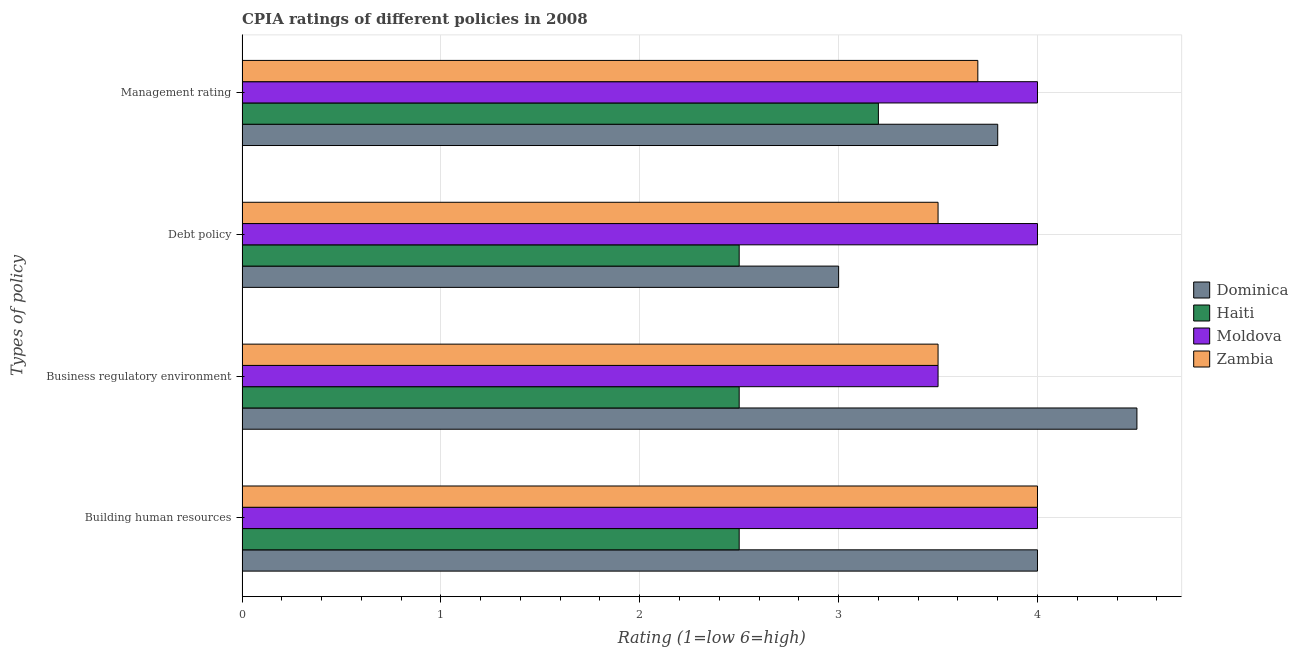How many groups of bars are there?
Your answer should be very brief. 4. Are the number of bars on each tick of the Y-axis equal?
Your response must be concise. Yes. How many bars are there on the 1st tick from the top?
Give a very brief answer. 4. What is the label of the 2nd group of bars from the top?
Provide a short and direct response. Debt policy. What is the cpia rating of building human resources in Haiti?
Offer a terse response. 2.5. Across all countries, what is the maximum cpia rating of management?
Provide a succinct answer. 4. Across all countries, what is the minimum cpia rating of management?
Your answer should be compact. 3.2. In which country was the cpia rating of business regulatory environment maximum?
Offer a very short reply. Dominica. In which country was the cpia rating of debt policy minimum?
Provide a succinct answer. Haiti. What is the difference between the cpia rating of debt policy in Dominica and the cpia rating of business regulatory environment in Zambia?
Your answer should be compact. -0.5. What is the average cpia rating of debt policy per country?
Offer a very short reply. 3.25. What is the difference between the cpia rating of business regulatory environment and cpia rating of building human resources in Dominica?
Provide a short and direct response. 0.5. In how many countries, is the cpia rating of debt policy greater than the average cpia rating of debt policy taken over all countries?
Make the answer very short. 2. Is it the case that in every country, the sum of the cpia rating of debt policy and cpia rating of business regulatory environment is greater than the sum of cpia rating of building human resources and cpia rating of management?
Keep it short and to the point. No. What does the 2nd bar from the top in Business regulatory environment represents?
Make the answer very short. Moldova. What does the 3rd bar from the bottom in Building human resources represents?
Your answer should be compact. Moldova. How many bars are there?
Give a very brief answer. 16. Are all the bars in the graph horizontal?
Your response must be concise. Yes. What is the difference between two consecutive major ticks on the X-axis?
Your response must be concise. 1. Does the graph contain any zero values?
Your answer should be compact. No. Does the graph contain grids?
Make the answer very short. Yes. Where does the legend appear in the graph?
Provide a short and direct response. Center right. What is the title of the graph?
Provide a short and direct response. CPIA ratings of different policies in 2008. What is the label or title of the X-axis?
Your answer should be compact. Rating (1=low 6=high). What is the label or title of the Y-axis?
Your answer should be compact. Types of policy. What is the Rating (1=low 6=high) in Dominica in Building human resources?
Keep it short and to the point. 4. What is the Rating (1=low 6=high) of Haiti in Building human resources?
Keep it short and to the point. 2.5. What is the Rating (1=low 6=high) of Zambia in Building human resources?
Offer a very short reply. 4. What is the Rating (1=low 6=high) of Haiti in Business regulatory environment?
Your answer should be very brief. 2.5. What is the Rating (1=low 6=high) in Haiti in Debt policy?
Make the answer very short. 2.5. What is the Rating (1=low 6=high) of Moldova in Debt policy?
Offer a very short reply. 4. What is the Rating (1=low 6=high) of Zambia in Debt policy?
Keep it short and to the point. 3.5. What is the Rating (1=low 6=high) in Dominica in Management rating?
Provide a succinct answer. 3.8. What is the Rating (1=low 6=high) of Moldova in Management rating?
Keep it short and to the point. 4. Across all Types of policy, what is the maximum Rating (1=low 6=high) of Moldova?
Offer a terse response. 4. Across all Types of policy, what is the minimum Rating (1=low 6=high) of Dominica?
Your answer should be compact. 3. What is the total Rating (1=low 6=high) of Haiti in the graph?
Make the answer very short. 10.7. What is the total Rating (1=low 6=high) in Moldova in the graph?
Offer a terse response. 15.5. What is the total Rating (1=low 6=high) in Zambia in the graph?
Offer a terse response. 14.7. What is the difference between the Rating (1=low 6=high) of Haiti in Building human resources and that in Business regulatory environment?
Your answer should be very brief. 0. What is the difference between the Rating (1=low 6=high) in Moldova in Building human resources and that in Business regulatory environment?
Offer a very short reply. 0.5. What is the difference between the Rating (1=low 6=high) in Zambia in Building human resources and that in Business regulatory environment?
Your answer should be compact. 0.5. What is the difference between the Rating (1=low 6=high) of Moldova in Building human resources and that in Debt policy?
Offer a very short reply. 0. What is the difference between the Rating (1=low 6=high) of Zambia in Building human resources and that in Debt policy?
Your answer should be compact. 0.5. What is the difference between the Rating (1=low 6=high) in Dominica in Building human resources and that in Management rating?
Provide a succinct answer. 0.2. What is the difference between the Rating (1=low 6=high) in Haiti in Building human resources and that in Management rating?
Keep it short and to the point. -0.7. What is the difference between the Rating (1=low 6=high) of Dominica in Business regulatory environment and that in Debt policy?
Keep it short and to the point. 1.5. What is the difference between the Rating (1=low 6=high) of Zambia in Business regulatory environment and that in Debt policy?
Provide a succinct answer. 0. What is the difference between the Rating (1=low 6=high) in Dominica in Business regulatory environment and that in Management rating?
Ensure brevity in your answer.  0.7. What is the difference between the Rating (1=low 6=high) of Moldova in Business regulatory environment and that in Management rating?
Keep it short and to the point. -0.5. What is the difference between the Rating (1=low 6=high) in Zambia in Business regulatory environment and that in Management rating?
Give a very brief answer. -0.2. What is the difference between the Rating (1=low 6=high) in Haiti in Debt policy and that in Management rating?
Ensure brevity in your answer.  -0.7. What is the difference between the Rating (1=low 6=high) in Moldova in Debt policy and that in Management rating?
Make the answer very short. 0. What is the difference between the Rating (1=low 6=high) in Dominica in Building human resources and the Rating (1=low 6=high) in Moldova in Business regulatory environment?
Your response must be concise. 0.5. What is the difference between the Rating (1=low 6=high) in Haiti in Building human resources and the Rating (1=low 6=high) in Moldova in Business regulatory environment?
Keep it short and to the point. -1. What is the difference between the Rating (1=low 6=high) of Moldova in Building human resources and the Rating (1=low 6=high) of Zambia in Business regulatory environment?
Provide a succinct answer. 0.5. What is the difference between the Rating (1=low 6=high) in Dominica in Building human resources and the Rating (1=low 6=high) in Haiti in Debt policy?
Ensure brevity in your answer.  1.5. What is the difference between the Rating (1=low 6=high) of Dominica in Building human resources and the Rating (1=low 6=high) of Zambia in Debt policy?
Ensure brevity in your answer.  0.5. What is the difference between the Rating (1=low 6=high) of Haiti in Building human resources and the Rating (1=low 6=high) of Zambia in Debt policy?
Ensure brevity in your answer.  -1. What is the difference between the Rating (1=low 6=high) in Dominica in Building human resources and the Rating (1=low 6=high) in Moldova in Management rating?
Give a very brief answer. 0. What is the difference between the Rating (1=low 6=high) in Haiti in Building human resources and the Rating (1=low 6=high) in Moldova in Management rating?
Your answer should be very brief. -1.5. What is the difference between the Rating (1=low 6=high) in Haiti in Building human resources and the Rating (1=low 6=high) in Zambia in Management rating?
Your answer should be very brief. -1.2. What is the difference between the Rating (1=low 6=high) in Dominica in Business regulatory environment and the Rating (1=low 6=high) in Moldova in Debt policy?
Offer a terse response. 0.5. What is the difference between the Rating (1=low 6=high) of Dominica in Business regulatory environment and the Rating (1=low 6=high) of Zambia in Debt policy?
Your response must be concise. 1. What is the difference between the Rating (1=low 6=high) in Haiti in Business regulatory environment and the Rating (1=low 6=high) in Moldova in Debt policy?
Provide a succinct answer. -1.5. What is the difference between the Rating (1=low 6=high) in Haiti in Business regulatory environment and the Rating (1=low 6=high) in Zambia in Debt policy?
Offer a very short reply. -1. What is the difference between the Rating (1=low 6=high) in Dominica in Business regulatory environment and the Rating (1=low 6=high) in Zambia in Management rating?
Offer a terse response. 0.8. What is the difference between the Rating (1=low 6=high) in Dominica in Debt policy and the Rating (1=low 6=high) in Moldova in Management rating?
Make the answer very short. -1. What is the difference between the Rating (1=low 6=high) in Dominica in Debt policy and the Rating (1=low 6=high) in Zambia in Management rating?
Provide a succinct answer. -0.7. What is the difference between the Rating (1=low 6=high) in Haiti in Debt policy and the Rating (1=low 6=high) in Moldova in Management rating?
Offer a terse response. -1.5. What is the average Rating (1=low 6=high) in Dominica per Types of policy?
Give a very brief answer. 3.83. What is the average Rating (1=low 6=high) of Haiti per Types of policy?
Ensure brevity in your answer.  2.67. What is the average Rating (1=low 6=high) in Moldova per Types of policy?
Offer a very short reply. 3.88. What is the average Rating (1=low 6=high) of Zambia per Types of policy?
Offer a very short reply. 3.67. What is the difference between the Rating (1=low 6=high) of Dominica and Rating (1=low 6=high) of Haiti in Building human resources?
Ensure brevity in your answer.  1.5. What is the difference between the Rating (1=low 6=high) of Haiti and Rating (1=low 6=high) of Zambia in Building human resources?
Keep it short and to the point. -1.5. What is the difference between the Rating (1=low 6=high) of Moldova and Rating (1=low 6=high) of Zambia in Building human resources?
Ensure brevity in your answer.  0. What is the difference between the Rating (1=low 6=high) of Dominica and Rating (1=low 6=high) of Haiti in Business regulatory environment?
Ensure brevity in your answer.  2. What is the difference between the Rating (1=low 6=high) in Haiti and Rating (1=low 6=high) in Moldova in Business regulatory environment?
Your answer should be very brief. -1. What is the difference between the Rating (1=low 6=high) in Haiti and Rating (1=low 6=high) in Zambia in Business regulatory environment?
Make the answer very short. -1. What is the difference between the Rating (1=low 6=high) in Moldova and Rating (1=low 6=high) in Zambia in Business regulatory environment?
Give a very brief answer. 0. What is the difference between the Rating (1=low 6=high) of Moldova and Rating (1=low 6=high) of Zambia in Debt policy?
Offer a very short reply. 0.5. What is the difference between the Rating (1=low 6=high) in Dominica and Rating (1=low 6=high) in Haiti in Management rating?
Keep it short and to the point. 0.6. What is the difference between the Rating (1=low 6=high) in Dominica and Rating (1=low 6=high) in Moldova in Management rating?
Make the answer very short. -0.2. What is the difference between the Rating (1=low 6=high) in Haiti and Rating (1=low 6=high) in Moldova in Management rating?
Offer a terse response. -0.8. What is the ratio of the Rating (1=low 6=high) of Dominica in Building human resources to that in Business regulatory environment?
Make the answer very short. 0.89. What is the ratio of the Rating (1=low 6=high) of Haiti in Building human resources to that in Business regulatory environment?
Your response must be concise. 1. What is the ratio of the Rating (1=low 6=high) of Moldova in Building human resources to that in Business regulatory environment?
Make the answer very short. 1.14. What is the ratio of the Rating (1=low 6=high) in Zambia in Building human resources to that in Business regulatory environment?
Give a very brief answer. 1.14. What is the ratio of the Rating (1=low 6=high) of Dominica in Building human resources to that in Debt policy?
Your answer should be very brief. 1.33. What is the ratio of the Rating (1=low 6=high) of Moldova in Building human resources to that in Debt policy?
Keep it short and to the point. 1. What is the ratio of the Rating (1=low 6=high) of Dominica in Building human resources to that in Management rating?
Give a very brief answer. 1.05. What is the ratio of the Rating (1=low 6=high) in Haiti in Building human resources to that in Management rating?
Ensure brevity in your answer.  0.78. What is the ratio of the Rating (1=low 6=high) in Zambia in Building human resources to that in Management rating?
Your answer should be compact. 1.08. What is the ratio of the Rating (1=low 6=high) of Zambia in Business regulatory environment to that in Debt policy?
Keep it short and to the point. 1. What is the ratio of the Rating (1=low 6=high) of Dominica in Business regulatory environment to that in Management rating?
Offer a very short reply. 1.18. What is the ratio of the Rating (1=low 6=high) in Haiti in Business regulatory environment to that in Management rating?
Offer a terse response. 0.78. What is the ratio of the Rating (1=low 6=high) of Zambia in Business regulatory environment to that in Management rating?
Give a very brief answer. 0.95. What is the ratio of the Rating (1=low 6=high) in Dominica in Debt policy to that in Management rating?
Offer a terse response. 0.79. What is the ratio of the Rating (1=low 6=high) in Haiti in Debt policy to that in Management rating?
Ensure brevity in your answer.  0.78. What is the ratio of the Rating (1=low 6=high) of Moldova in Debt policy to that in Management rating?
Offer a very short reply. 1. What is the ratio of the Rating (1=low 6=high) of Zambia in Debt policy to that in Management rating?
Ensure brevity in your answer.  0.95. What is the difference between the highest and the second highest Rating (1=low 6=high) of Zambia?
Ensure brevity in your answer.  0.3. What is the difference between the highest and the lowest Rating (1=low 6=high) in Haiti?
Ensure brevity in your answer.  0.7. 